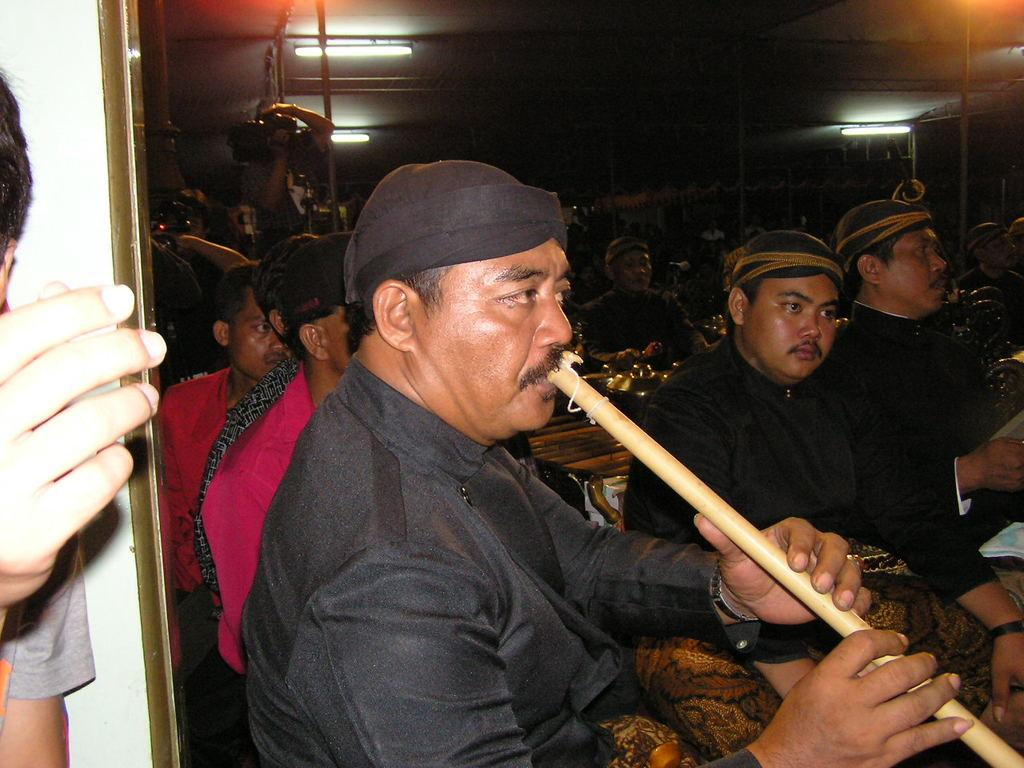What is the main subject of the image? There is a person in the image. What is the person wearing on their head? The person is wearing a cap. What is the person doing in the image? The person is playing a musical instrument. Can you describe the background of the image? There are many people in the background of the image. What can be seen on the ceiling in the image? There are lights on the ceiling. What type of shade does the boy desire in the image? There is no boy or desire mentioned in the image, and no shade is present. 